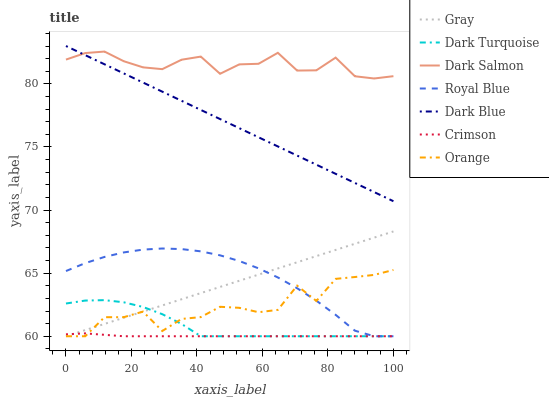Does Crimson have the minimum area under the curve?
Answer yes or no. Yes. Does Dark Salmon have the maximum area under the curve?
Answer yes or no. Yes. Does Royal Blue have the minimum area under the curve?
Answer yes or no. No. Does Royal Blue have the maximum area under the curve?
Answer yes or no. No. Is Gray the smoothest?
Answer yes or no. Yes. Is Orange the roughest?
Answer yes or no. Yes. Is Royal Blue the smoothest?
Answer yes or no. No. Is Royal Blue the roughest?
Answer yes or no. No. Does Gray have the lowest value?
Answer yes or no. Yes. Does Dark Salmon have the lowest value?
Answer yes or no. No. Does Dark Blue have the highest value?
Answer yes or no. Yes. Does Royal Blue have the highest value?
Answer yes or no. No. Is Dark Turquoise less than Dark Salmon?
Answer yes or no. Yes. Is Dark Blue greater than Dark Turquoise?
Answer yes or no. Yes. Does Dark Salmon intersect Dark Blue?
Answer yes or no. Yes. Is Dark Salmon less than Dark Blue?
Answer yes or no. No. Is Dark Salmon greater than Dark Blue?
Answer yes or no. No. Does Dark Turquoise intersect Dark Salmon?
Answer yes or no. No. 